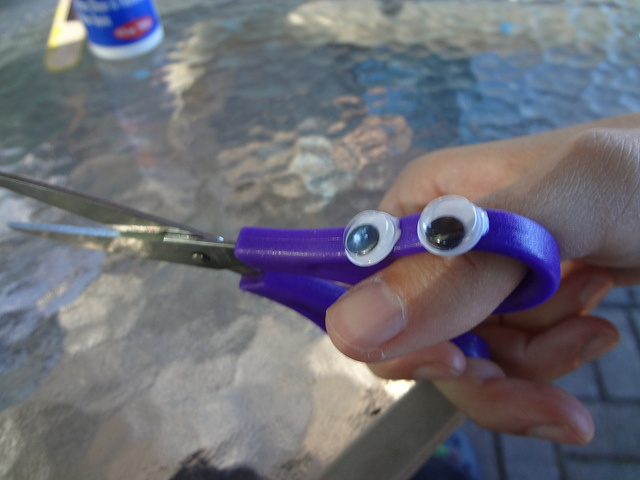Describe the objects in this image and their specific colors. I can see people in gray, maroon, and black tones and scissors in gray, navy, black, and darkblue tones in this image. 